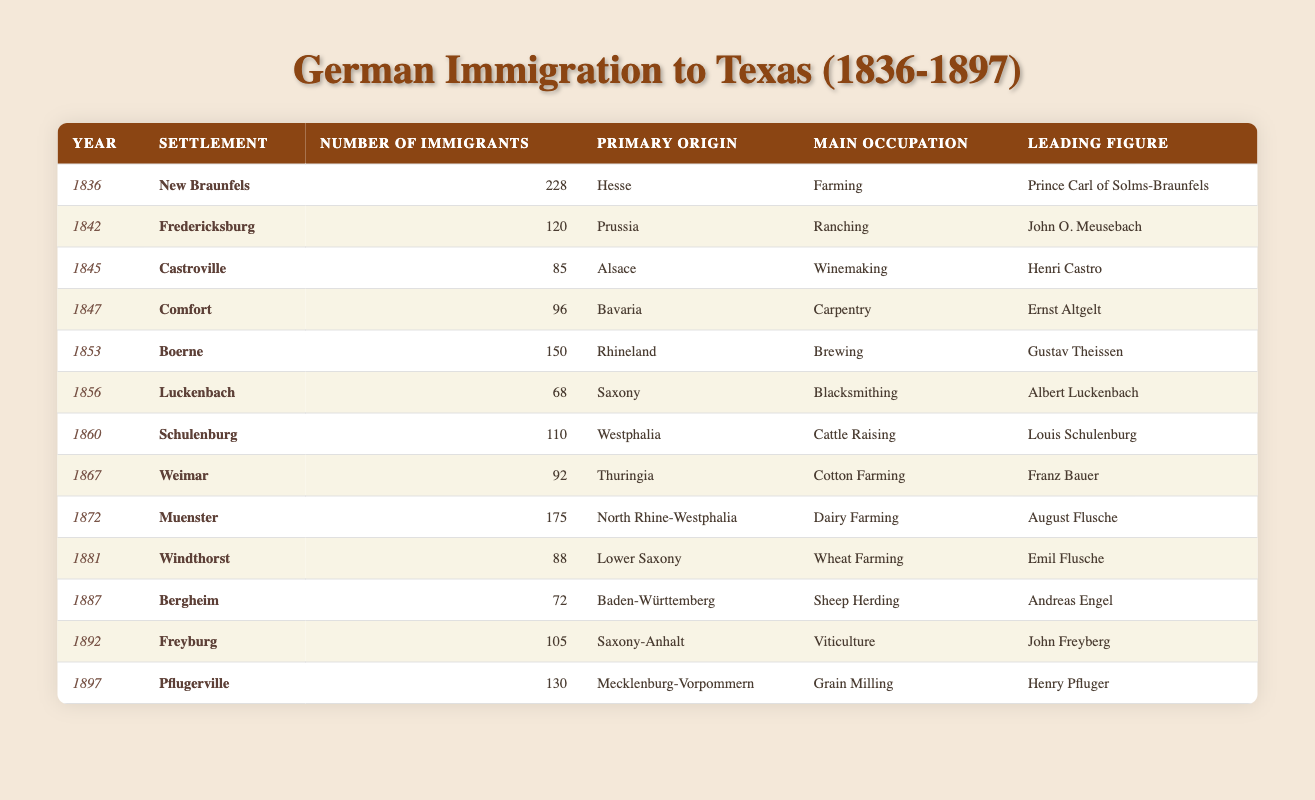What year saw the highest number of German immigrants to Texas? The table shows the number of immigrants for each year. The highest count is in 1836 with 228 immigrants to New Braunfels.
Answer: 1836 Which primary origin contributed the most immigrants to Texas? Looking at the table, the primary origin "Hesse" has the highest number of immigrants (228 in 1836).
Answer: Hesse What is the total number of immigrants recorded between 1840 and 1850? Summing the immigrants from 1842 (120) to 1847 (96) gives: 120 + 85 + 96 = 301.
Answer: 301 Did the settlement of Fredericksburg attract more or fewer immigrants than that of Castroville? Fredericksburg attracted 120 immigrants while Castroville attracted 85, thus Fredericksburg had more.
Answer: More What was the leading figure for the settlement of Muenster? Referring to the table, the leading figure for Muenster is August Flusche.
Answer: August Flusche How many immigrants came from Bavaria compared to those from Prussia? From the table, Bavaria had 96 immigrants (Comfort) and Prussia had 120 (Fredericksburg). Comparing these numbers: 120 (Prussia) vs 96 (Bavaria) shows that Prussia had more.
Answer: Prussia had more What was the common occupation among the German immigrants in Texas? Reviewing the table, the main occupations vary, but "Farming" appears in multiple years.
Answer: Farming Which settlement experienced the highest influx of German immigrants in the year 1872? In 1872, Muenster had 175 immigrants, making it the highest that year according to the table.
Answer: Muenster What percentage of the total immigrants in the year 1860 were involved in cattle raising? In 1860, 110 immigrants were recorded; of these, all were involved in cattle raising, so the percentage is 110/110 which is 100%.
Answer: 100% Which state's primary origin had the occupation of winemaking? The table indicates that the occupation of winemaking is associated with immigrants from Alsace in 1845.
Answer: Alsace 